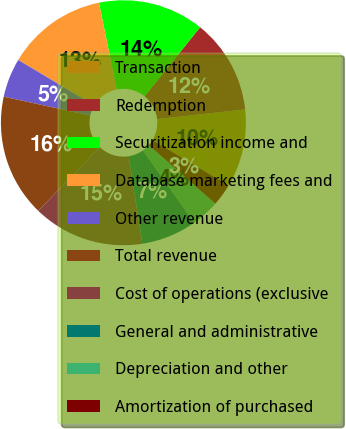Convert chart. <chart><loc_0><loc_0><loc_500><loc_500><pie_chart><fcel>Transaction<fcel>Redemption<fcel>Securitization income and<fcel>Database marketing fees and<fcel>Other revenue<fcel>Total revenue<fcel>Cost of operations (exclusive<fcel>General and administrative<fcel>Depreciation and other<fcel>Amortization of purchased<nl><fcel>10.29%<fcel>12.5%<fcel>13.97%<fcel>13.24%<fcel>5.15%<fcel>16.18%<fcel>14.71%<fcel>7.35%<fcel>3.68%<fcel>2.94%<nl></chart> 